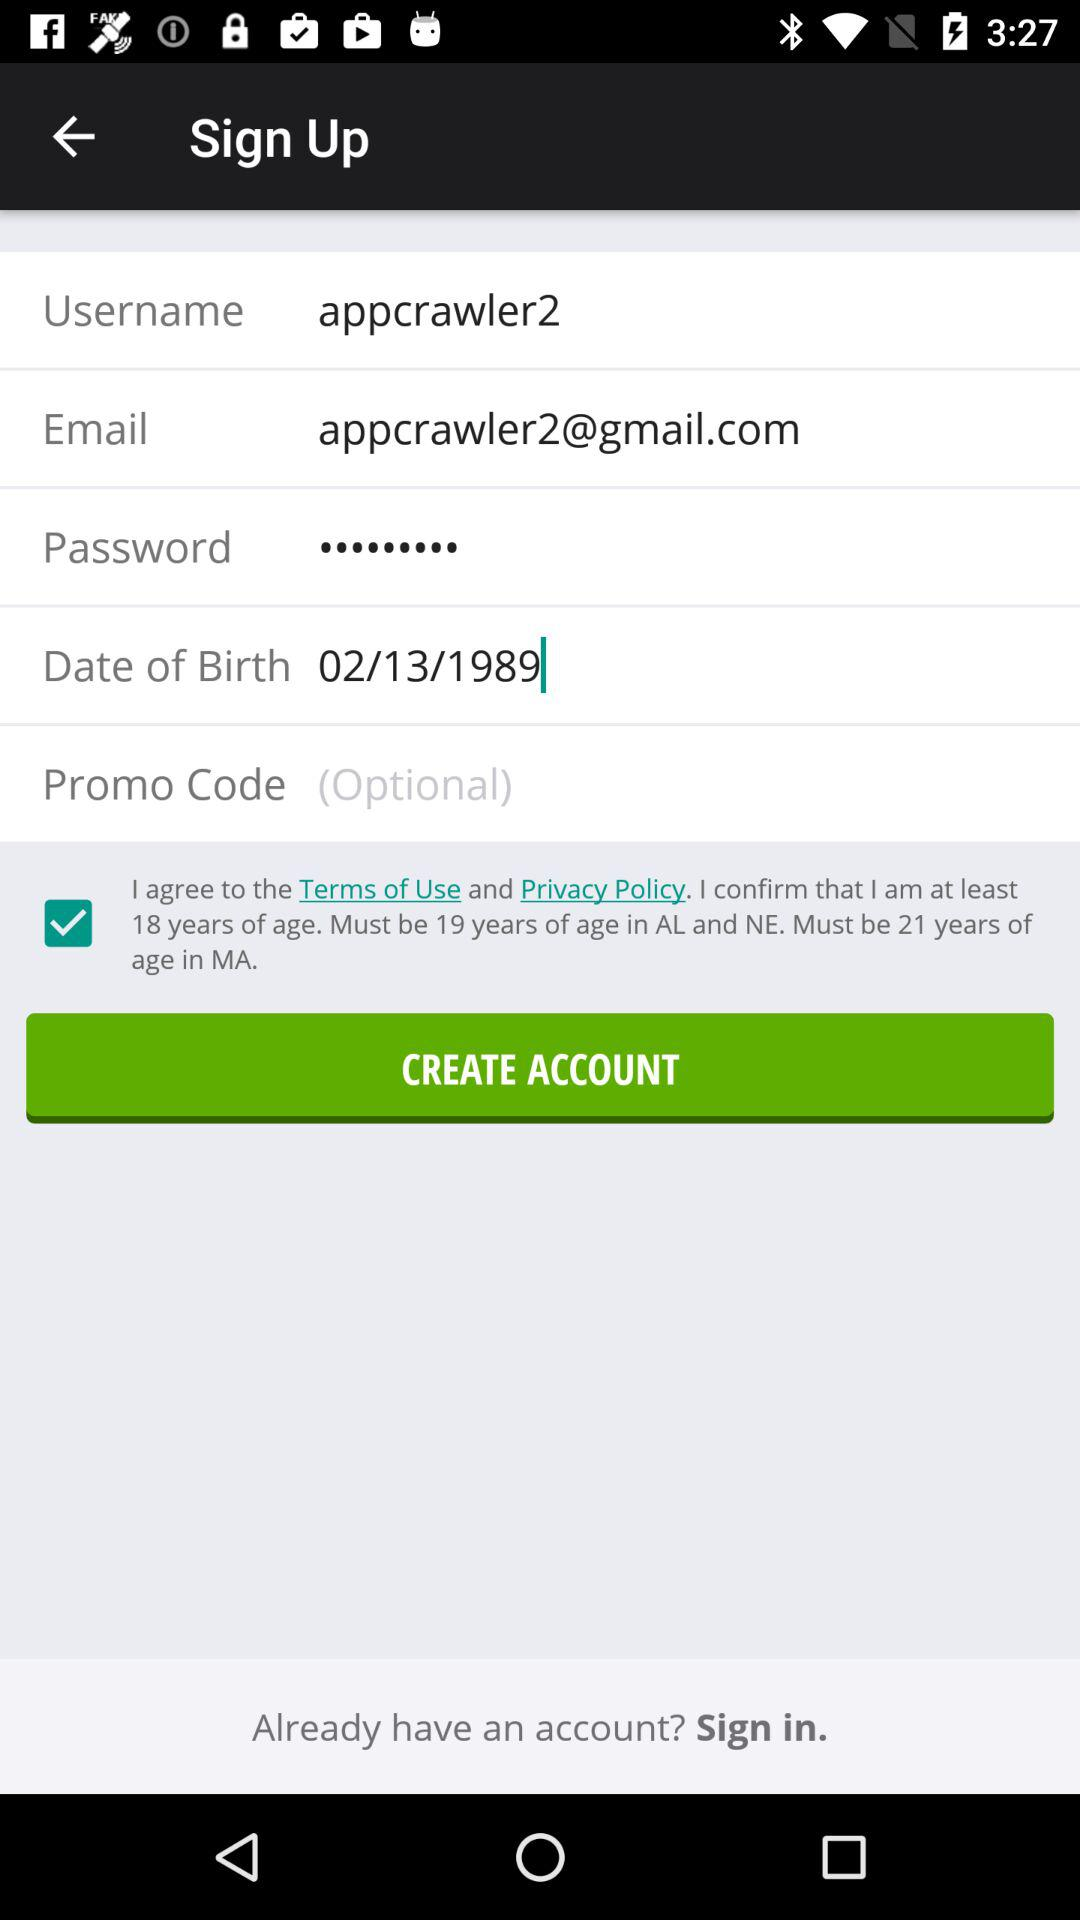What is the required age for signup? The required age for signup is 18 years. 